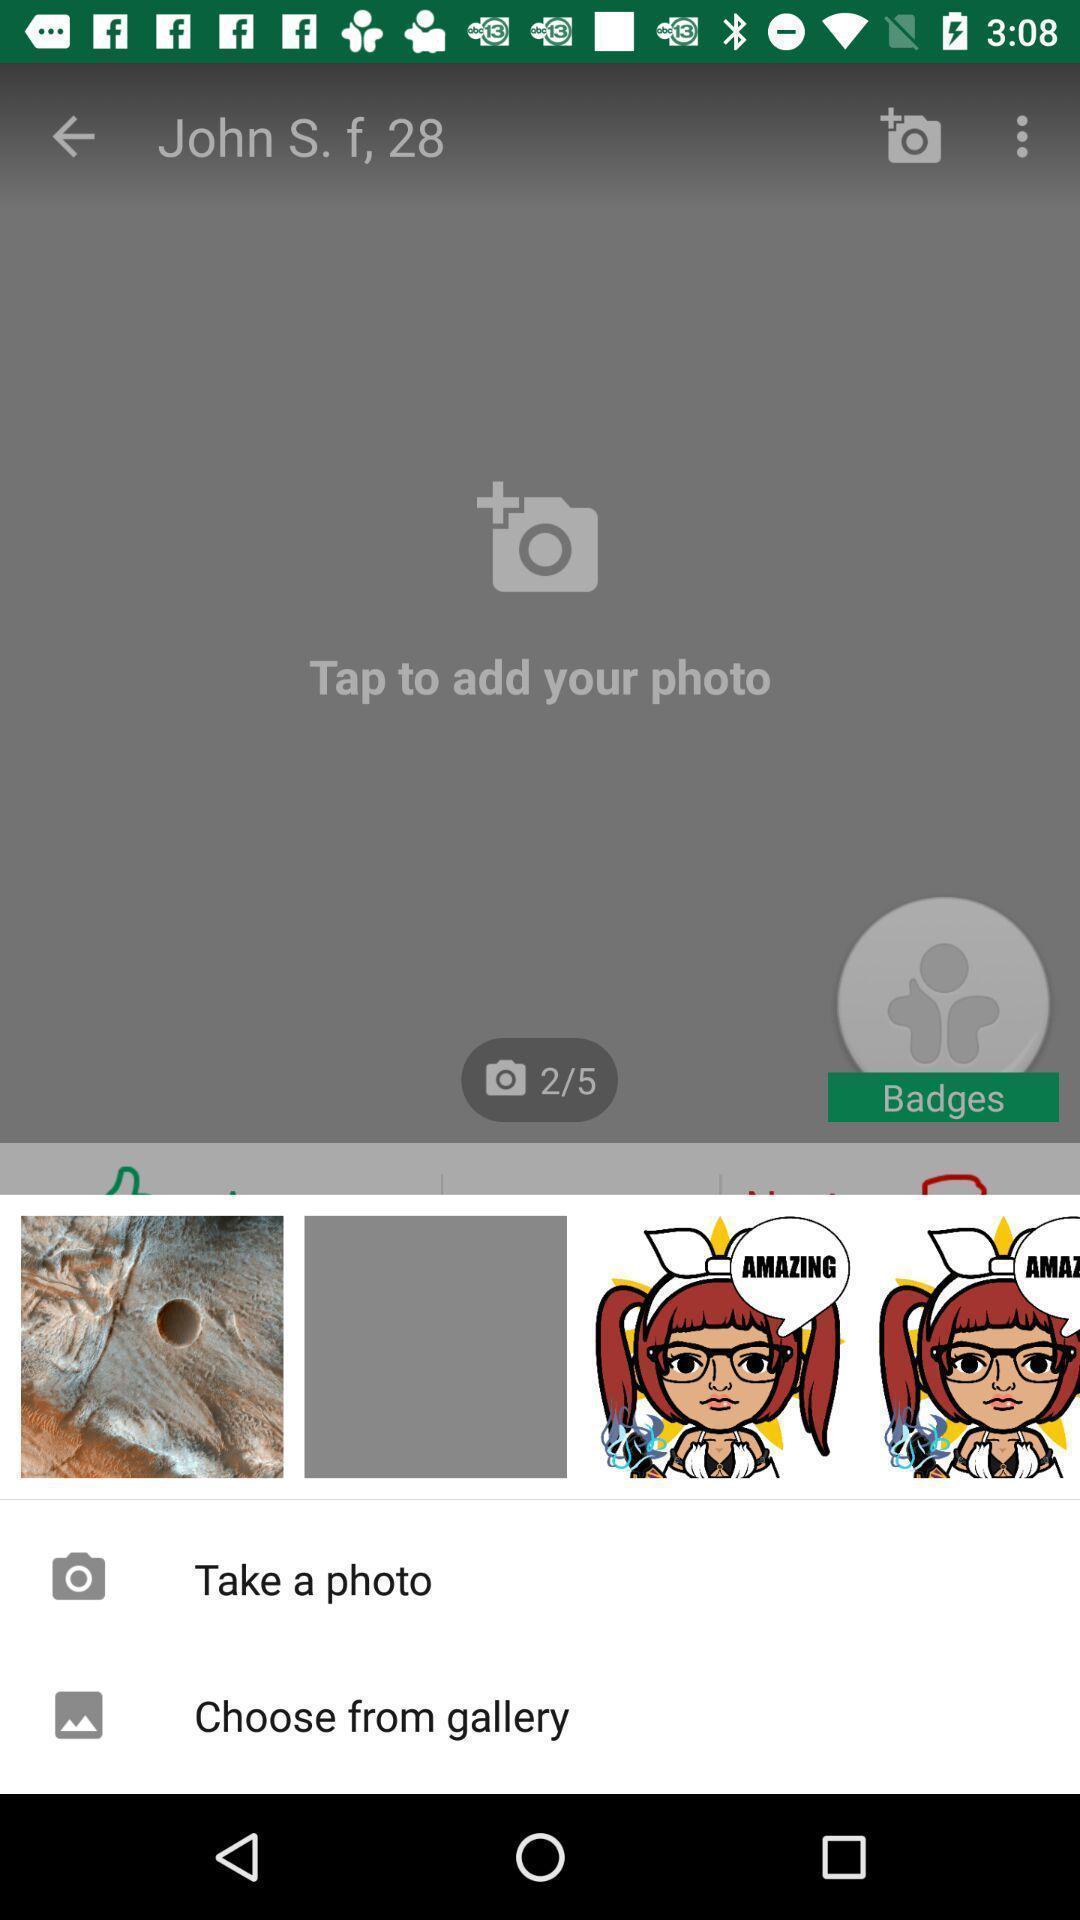Please provide a description for this image. Profile editing page. 